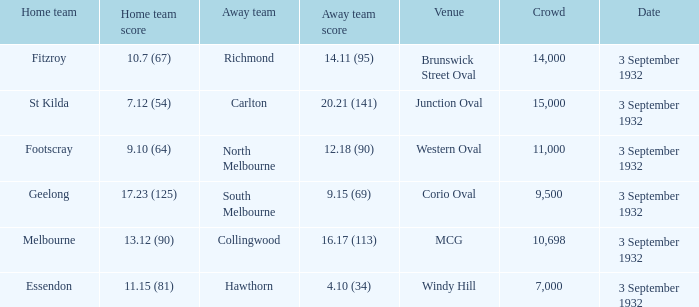What is the name of the Venue for the team that has an Away team score of 14.11 (95)? Brunswick Street Oval. 